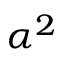<formula> <loc_0><loc_0><loc_500><loc_500>\alpha ^ { 2 }</formula> 